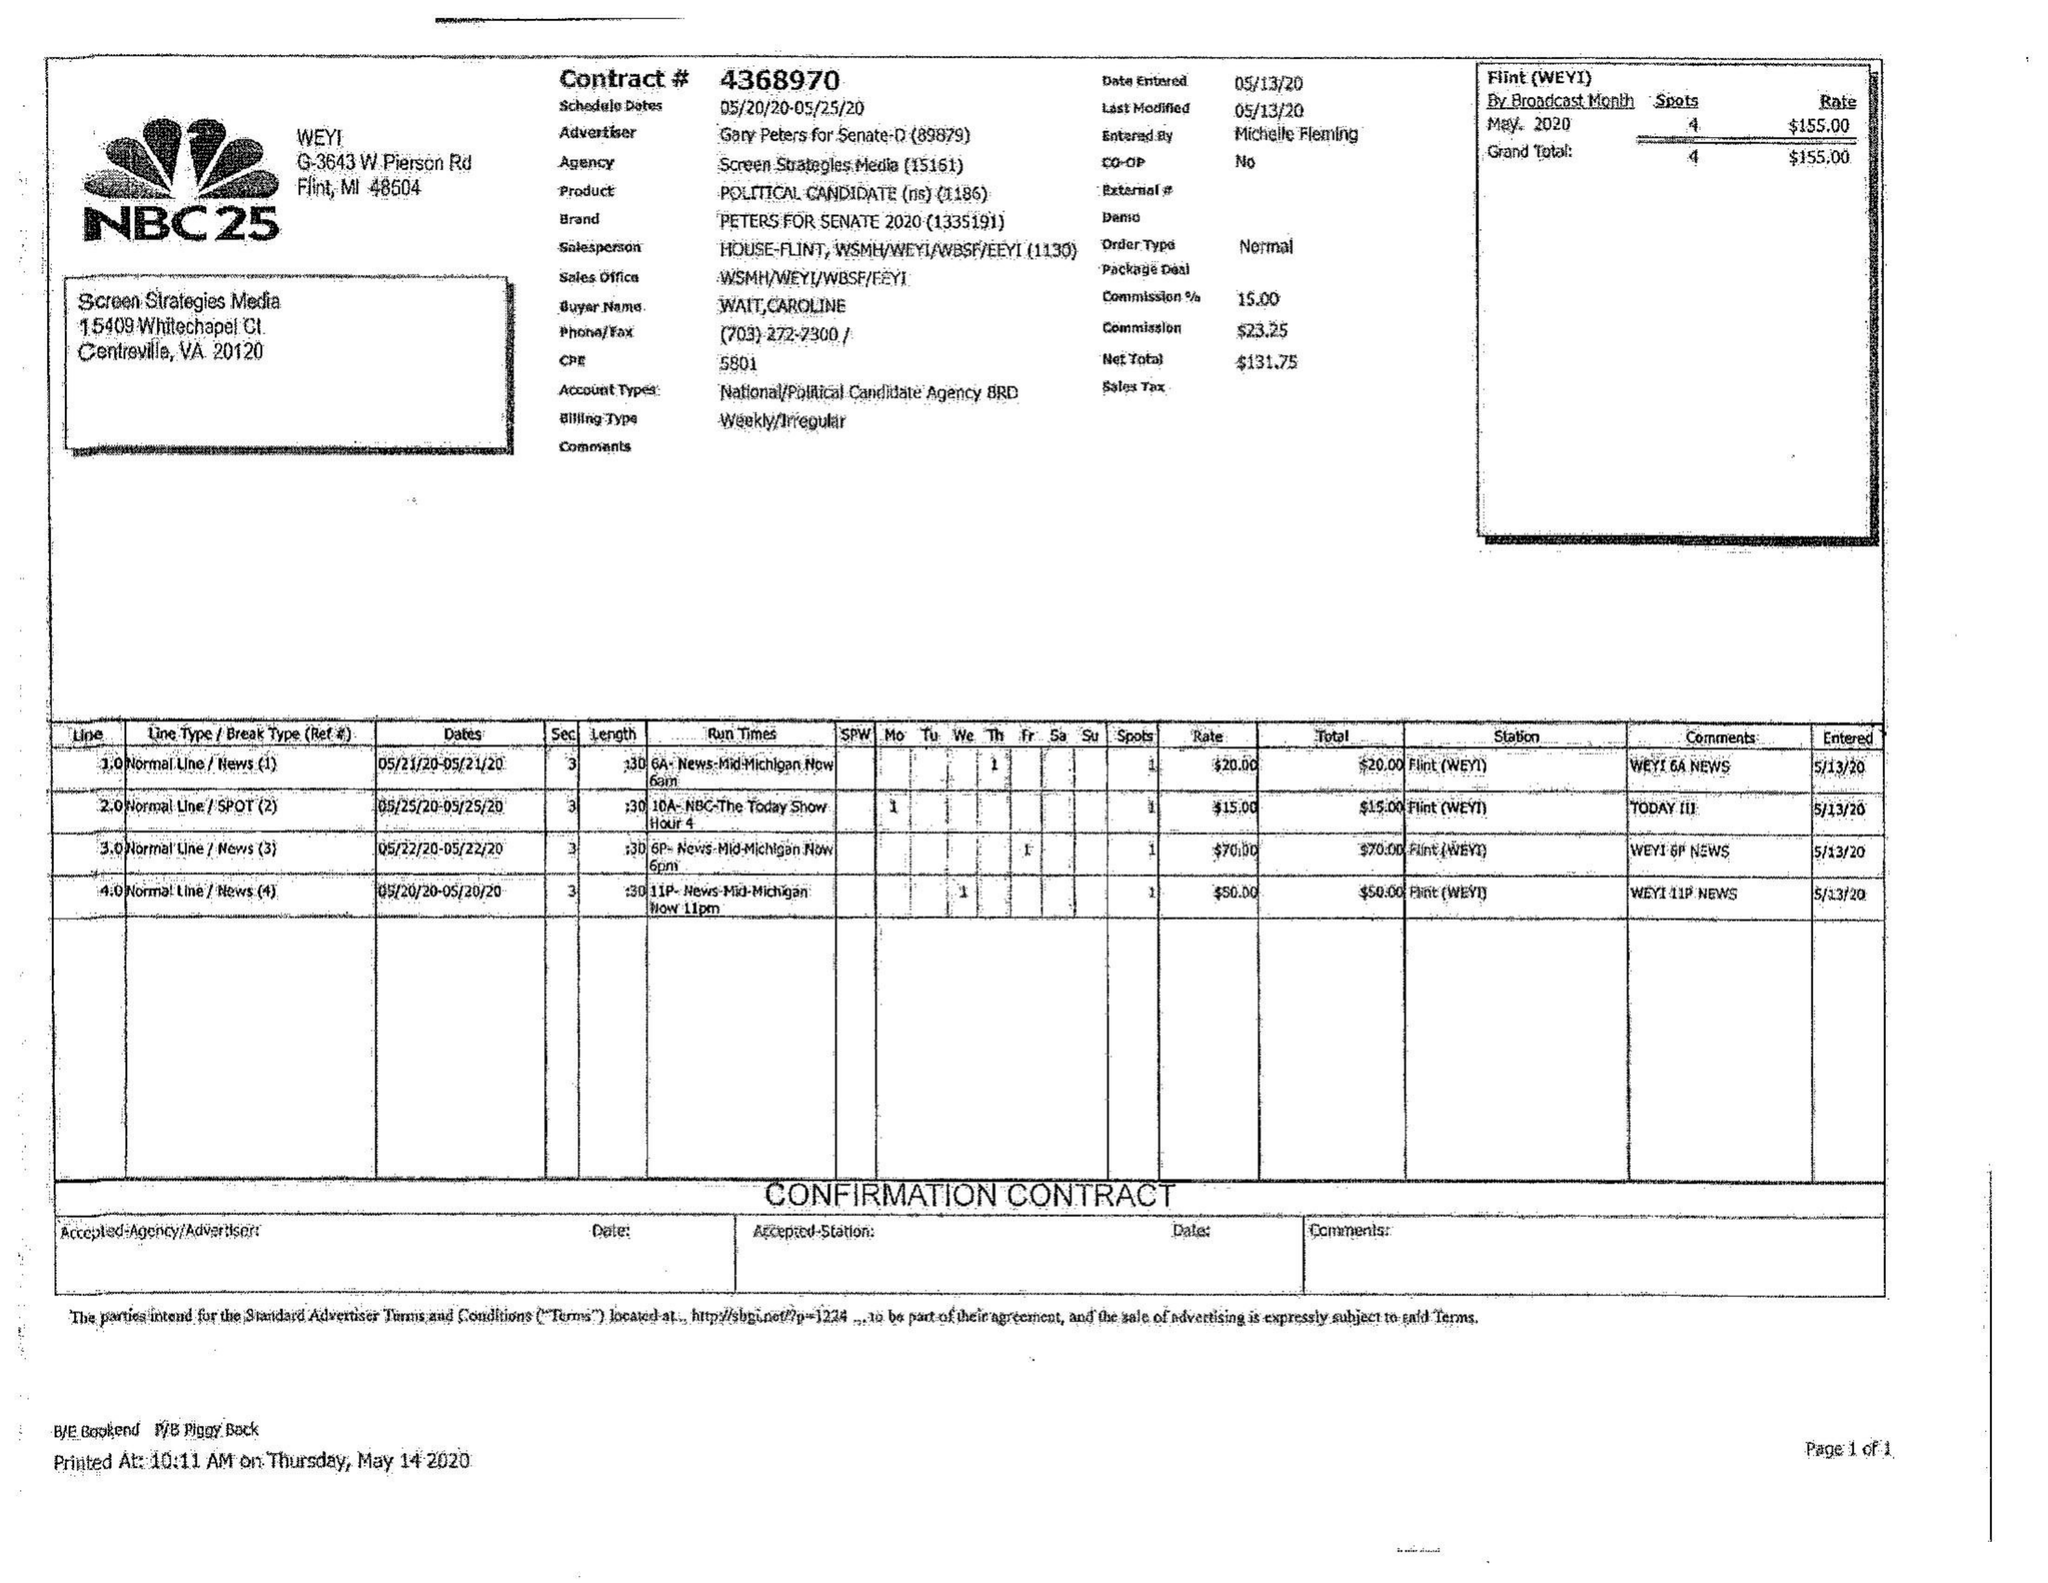What is the value for the gross_amount?
Answer the question using a single word or phrase. 155.00 